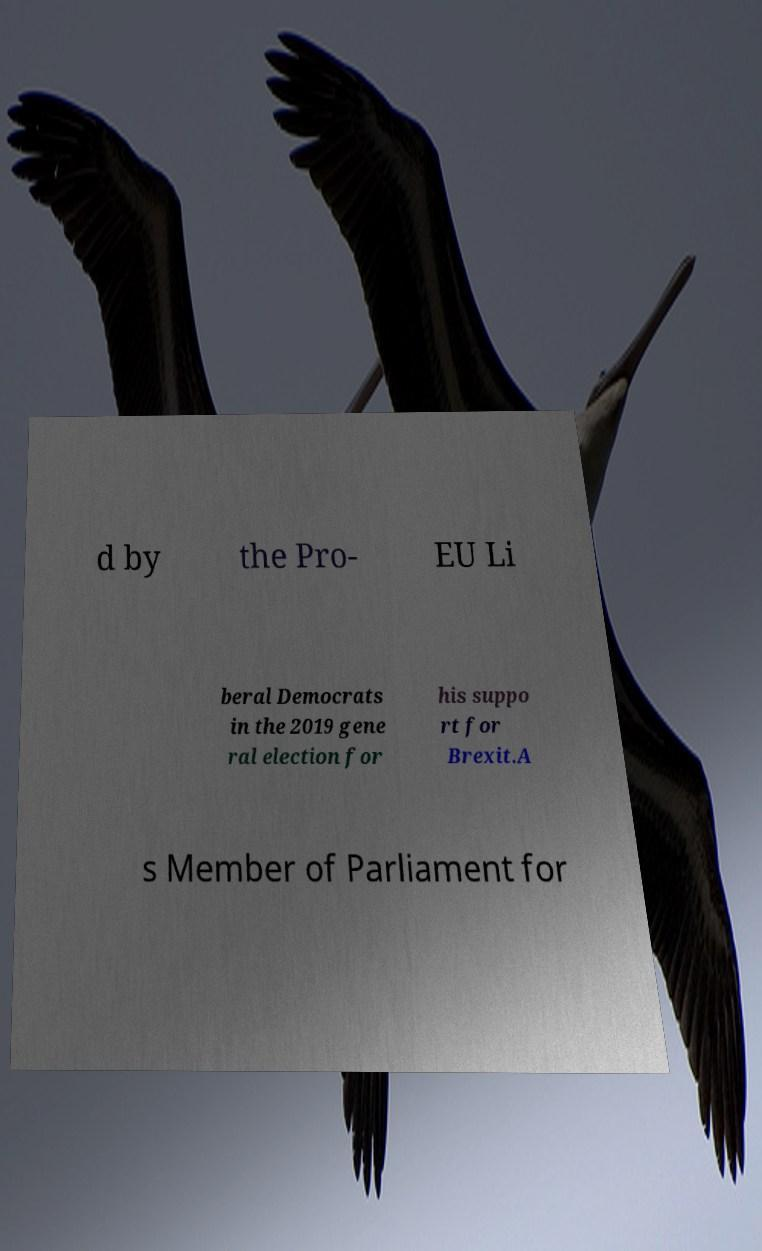Please read and relay the text visible in this image. What does it say? d by the Pro- EU Li beral Democrats in the 2019 gene ral election for his suppo rt for Brexit.A s Member of Parliament for 